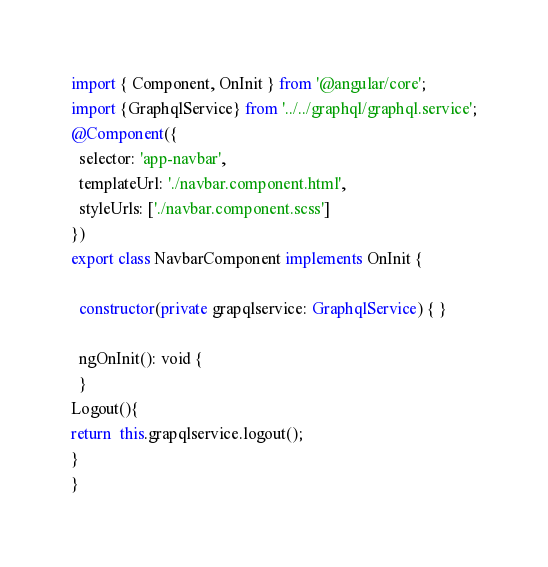Convert code to text. <code><loc_0><loc_0><loc_500><loc_500><_TypeScript_>import { Component, OnInit } from '@angular/core';
import {GraphqlService} from '../../graphql/graphql.service';
@Component({
  selector: 'app-navbar',
  templateUrl: './navbar.component.html',
  styleUrls: ['./navbar.component.scss']
})
export class NavbarComponent implements OnInit {

  constructor(private grapqlservice: GraphqlService) { }

  ngOnInit(): void {
  }
Logout(){
return  this.grapqlservice.logout();
}
}
</code> 